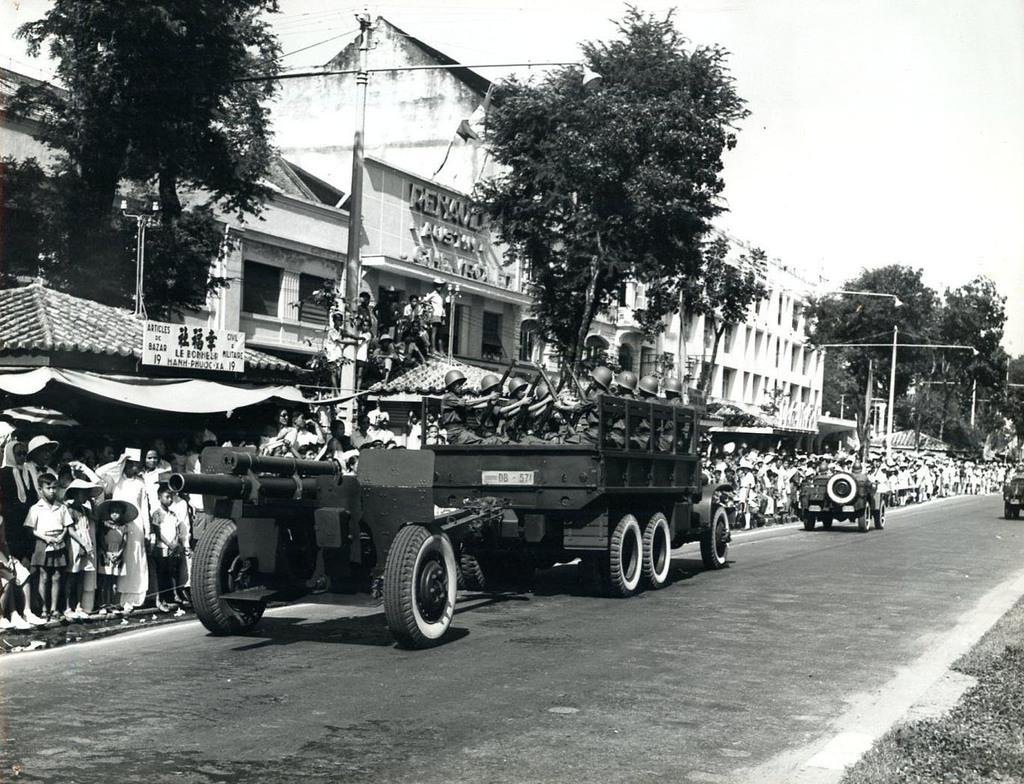Can you describe this image briefly? In the picture we can see a road on it we can see some army vehicles with army people sitting in it holding guns and beside them we can see many people are standing on the path near the buildings and trees and we can also see some poles on the path and behind the buildings we can see a sky. 